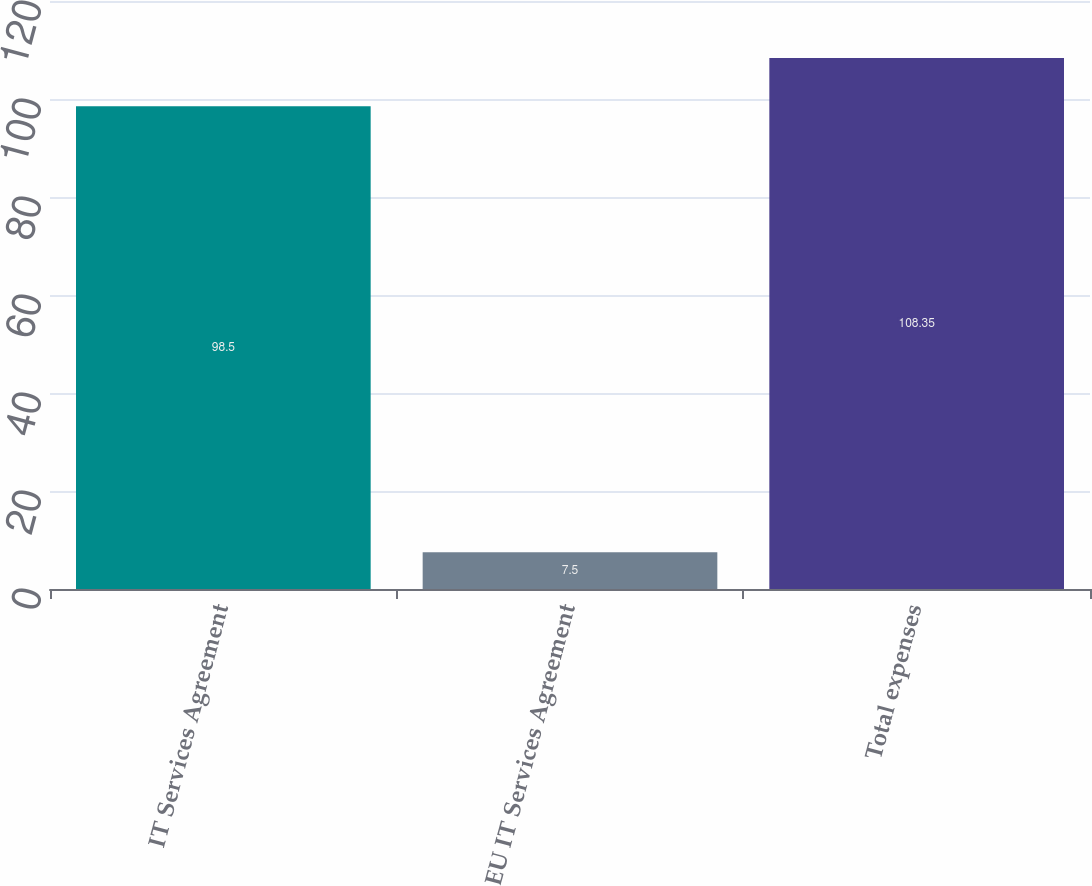Convert chart. <chart><loc_0><loc_0><loc_500><loc_500><bar_chart><fcel>IT Services Agreement<fcel>EU IT Services Agreement<fcel>Total expenses<nl><fcel>98.5<fcel>7.5<fcel>108.35<nl></chart> 